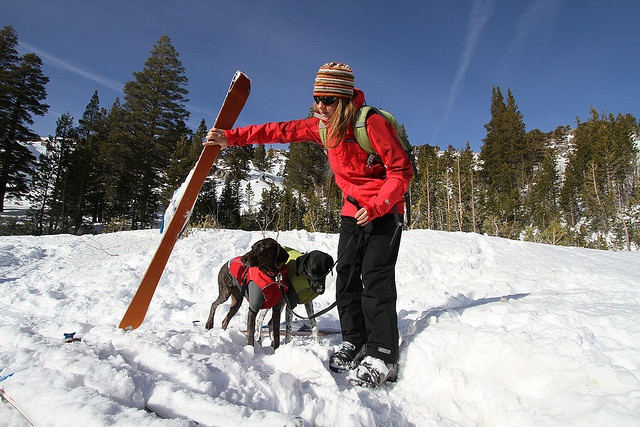Describe the objects in this image and their specific colors. I can see people in blue, black, brown, maroon, and red tones, dog in blue, black, gray, maroon, and red tones, snowboard in blue, maroon, brown, and black tones, dog in blue, black, gray, white, and darkgreen tones, and backpack in blue, gray, black, and olive tones in this image. 